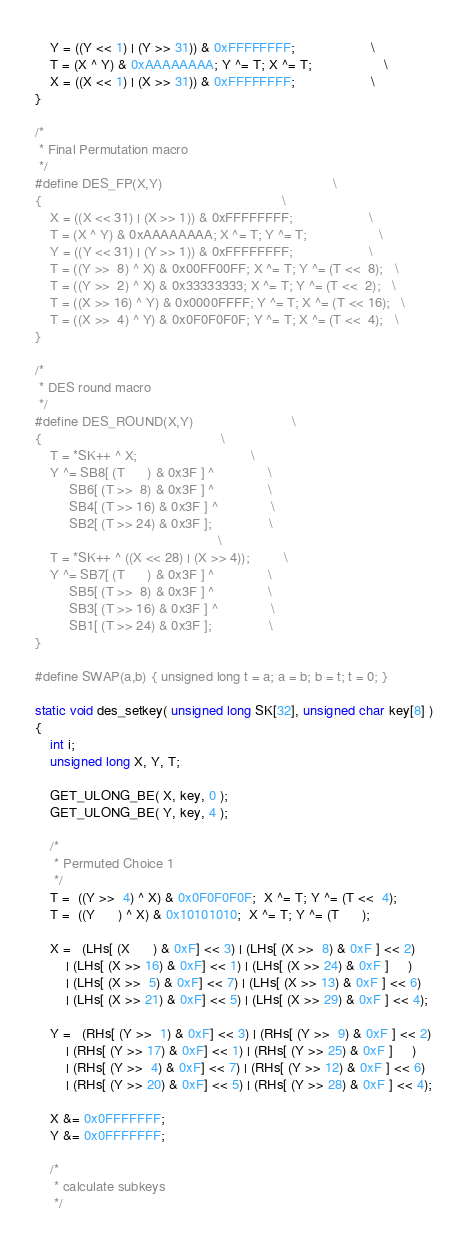<code> <loc_0><loc_0><loc_500><loc_500><_C_>    Y = ((Y << 1) | (Y >> 31)) & 0xFFFFFFFF;                    \
    T = (X ^ Y) & 0xAAAAAAAA; Y ^= T; X ^= T;                   \
    X = ((X << 1) | (X >> 31)) & 0xFFFFFFFF;                    \
}

/*
 * Final Permutation macro
 */
#define DES_FP(X,Y)                                             \
{                                                               \
    X = ((X << 31) | (X >> 1)) & 0xFFFFFFFF;                    \
    T = (X ^ Y) & 0xAAAAAAAA; X ^= T; Y ^= T;                   \
    Y = ((Y << 31) | (Y >> 1)) & 0xFFFFFFFF;                    \
    T = ((Y >>  8) ^ X) & 0x00FF00FF; X ^= T; Y ^= (T <<  8);   \
    T = ((Y >>  2) ^ X) & 0x33333333; X ^= T; Y ^= (T <<  2);   \
    T = ((X >> 16) ^ Y) & 0x0000FFFF; Y ^= T; X ^= (T << 16);   \
    T = ((X >>  4) ^ Y) & 0x0F0F0F0F; Y ^= T; X ^= (T <<  4);   \
}

/*
 * DES round macro
 */
#define DES_ROUND(X,Y)                          \
{                                               \
    T = *SK++ ^ X;                              \
    Y ^= SB8[ (T      ) & 0x3F ] ^              \
         SB6[ (T >>  8) & 0x3F ] ^              \
         SB4[ (T >> 16) & 0x3F ] ^              \
         SB2[ (T >> 24) & 0x3F ];               \
                                                \
    T = *SK++ ^ ((X << 28) | (X >> 4));         \
    Y ^= SB7[ (T      ) & 0x3F ] ^              \
         SB5[ (T >>  8) & 0x3F ] ^              \
         SB3[ (T >> 16) & 0x3F ] ^              \
         SB1[ (T >> 24) & 0x3F ];               \
}

#define SWAP(a,b) { unsigned long t = a; a = b; b = t; t = 0; }

static void des_setkey( unsigned long SK[32], unsigned char key[8] )
{
    int i;
    unsigned long X, Y, T;

    GET_ULONG_BE( X, key, 0 );
    GET_ULONG_BE( Y, key, 4 );

    /*
     * Permuted Choice 1
     */
    T =  ((Y >>  4) ^ X) & 0x0F0F0F0F;  X ^= T; Y ^= (T <<  4);
    T =  ((Y      ) ^ X) & 0x10101010;  X ^= T; Y ^= (T      );

    X =   (LHs[ (X      ) & 0xF] << 3) | (LHs[ (X >>  8) & 0xF ] << 2)
        | (LHs[ (X >> 16) & 0xF] << 1) | (LHs[ (X >> 24) & 0xF ]     )
        | (LHs[ (X >>  5) & 0xF] << 7) | (LHs[ (X >> 13) & 0xF ] << 6)
        | (LHs[ (X >> 21) & 0xF] << 5) | (LHs[ (X >> 29) & 0xF ] << 4);

    Y =   (RHs[ (Y >>  1) & 0xF] << 3) | (RHs[ (Y >>  9) & 0xF ] << 2)
        | (RHs[ (Y >> 17) & 0xF] << 1) | (RHs[ (Y >> 25) & 0xF ]     )
        | (RHs[ (Y >>  4) & 0xF] << 7) | (RHs[ (Y >> 12) & 0xF ] << 6)
        | (RHs[ (Y >> 20) & 0xF] << 5) | (RHs[ (Y >> 28) & 0xF ] << 4);

    X &= 0x0FFFFFFF;
    Y &= 0x0FFFFFFF;

    /*
     * calculate subkeys
     */</code> 